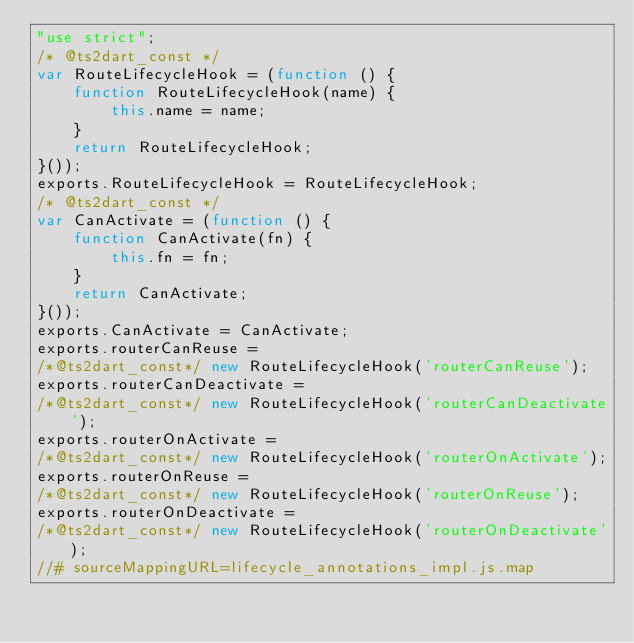Convert code to text. <code><loc_0><loc_0><loc_500><loc_500><_JavaScript_>"use strict";
/* @ts2dart_const */
var RouteLifecycleHook = (function () {
    function RouteLifecycleHook(name) {
        this.name = name;
    }
    return RouteLifecycleHook;
}());
exports.RouteLifecycleHook = RouteLifecycleHook;
/* @ts2dart_const */
var CanActivate = (function () {
    function CanActivate(fn) {
        this.fn = fn;
    }
    return CanActivate;
}());
exports.CanActivate = CanActivate;
exports.routerCanReuse = 
/*@ts2dart_const*/ new RouteLifecycleHook('routerCanReuse');
exports.routerCanDeactivate = 
/*@ts2dart_const*/ new RouteLifecycleHook('routerCanDeactivate');
exports.routerOnActivate = 
/*@ts2dart_const*/ new RouteLifecycleHook('routerOnActivate');
exports.routerOnReuse = 
/*@ts2dart_const*/ new RouteLifecycleHook('routerOnReuse');
exports.routerOnDeactivate = 
/*@ts2dart_const*/ new RouteLifecycleHook('routerOnDeactivate');
//# sourceMappingURL=lifecycle_annotations_impl.js.map</code> 